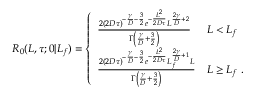Convert formula to latex. <formula><loc_0><loc_0><loc_500><loc_500>\begin{array} { r } { R _ { 0 } ( L , \tau ; 0 | L _ { f } ) = \left \{ \begin{array} { l l } { \frac { 2 ( 2 D \tau ) ^ { - \frac { \gamma } { D } - \frac { 3 } { 2 } } e ^ { - \frac { L ^ { 2 } } { 2 D \tau } } L ^ { \frac { 2 \gamma } { D } + 2 } } { \Gamma \left ( \frac { \gamma } { D } + \frac { 3 } { 2 } \right ) } } & { L < L _ { f } } \\ { \frac { 2 ( 2 D \tau ) ^ { - \frac { \gamma } { D } - \frac { 3 } { 2 } } e ^ { - \frac { L ^ { 2 } } { 2 D \tau } } L _ { f } ^ { \frac { 2 \gamma } { D } + 1 } L } { \Gamma \left ( \frac { \gamma } { D } + \frac { 3 } { 2 } \right ) } } & { L \geq L _ { f } \ . } \end{array} } \end{array}</formula> 